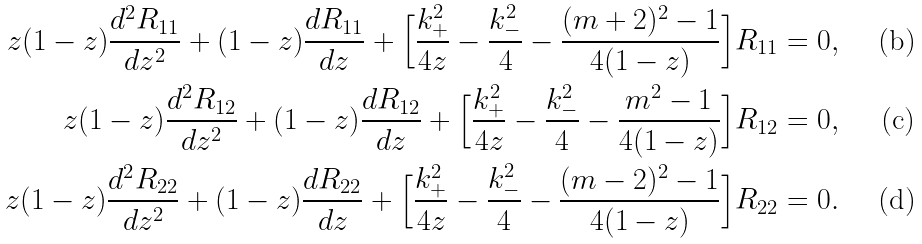<formula> <loc_0><loc_0><loc_500><loc_500>z ( 1 - z ) \frac { d ^ { 2 } R _ { 1 1 } } { d z ^ { 2 } } + ( 1 - z ) \frac { d R _ { 1 1 } } { d z } + \Big { [ } \frac { k _ { + } ^ { 2 } } { 4 z } - \frac { k _ { - } ^ { 2 } } { 4 } - \frac { ( m + 2 ) ^ { 2 } - 1 } { 4 ( 1 - z ) } \Big { ] } R _ { 1 1 } & = 0 , \\ z ( 1 - z ) \frac { d ^ { 2 } R _ { 1 2 } } { d z ^ { 2 } } + ( 1 - z ) \frac { d R _ { 1 2 } } { d z } + \Big { [ } \frac { k _ { + } ^ { 2 } } { 4 z } - \frac { k _ { - } ^ { 2 } } { 4 } - \frac { m ^ { 2 } - 1 } { 4 ( 1 - z ) } \Big { ] } R _ { 1 2 } & = 0 , \\ z ( 1 - z ) \frac { d ^ { 2 } R _ { 2 2 } } { d z ^ { 2 } } + ( 1 - z ) \frac { d R _ { 2 2 } } { d z } + \Big { [ } \frac { k _ { + } ^ { 2 } } { 4 z } - \frac { k _ { - } ^ { 2 } } { 4 } - \frac { ( m - 2 ) ^ { 2 } - 1 } { 4 ( 1 - z ) } \Big { ] } R _ { 2 2 } & = 0 .</formula> 